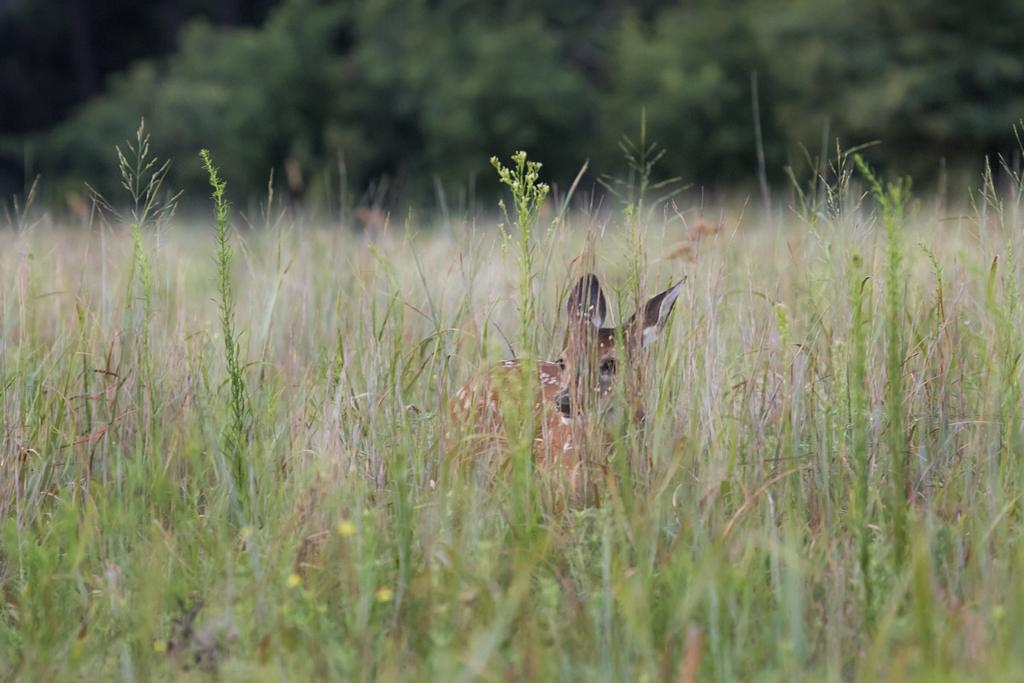What type of animal is in the image? The animal in the image is brown in color. What can be seen in the background of the image? There are trees and plants in the background of the image. What color are the plants in the image? The plants in the image are green in color. What type of liquid can be seen in the animal's bath in the image? There is no bath or liquid present in the image; it features an animal and plants in the background. 